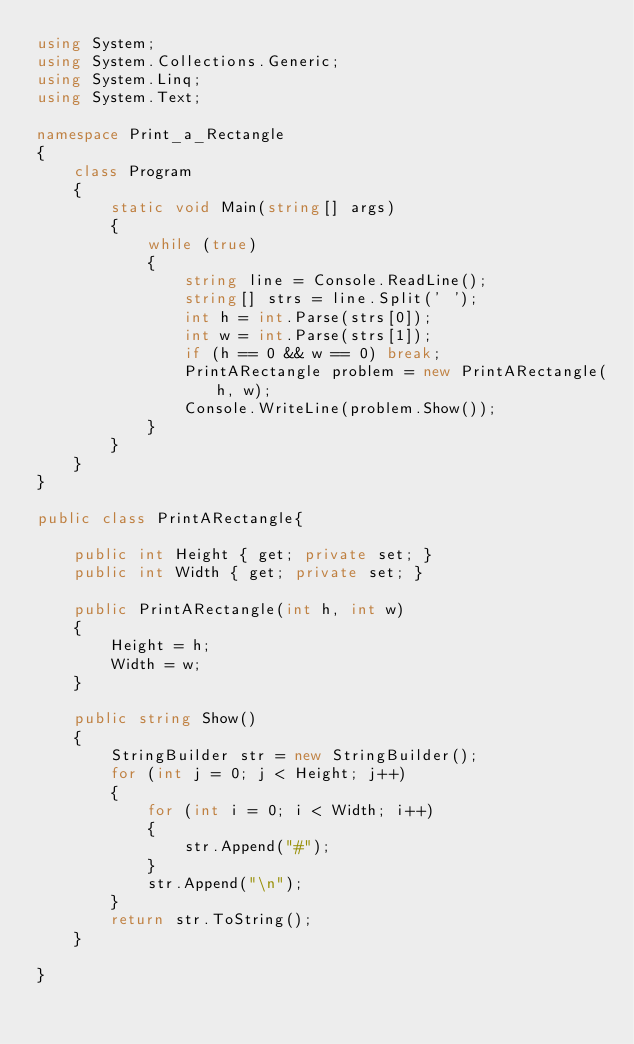Convert code to text. <code><loc_0><loc_0><loc_500><loc_500><_C#_>using System;
using System.Collections.Generic;
using System.Linq;
using System.Text;

namespace Print_a_Rectangle
{
    class Program
    {
        static void Main(string[] args)
        {
            while (true)
            {
                string line = Console.ReadLine();
                string[] strs = line.Split(' ');
                int h = int.Parse(strs[0]);
                int w = int.Parse(strs[1]);
                if (h == 0 && w == 0) break;
                PrintARectangle problem = new PrintARectangle(h, w);
                Console.WriteLine(problem.Show());
            }
        }
    }
}

public class PrintARectangle{

    public int Height { get; private set; }
    public int Width { get; private set; }

    public PrintARectangle(int h, int w)
    {
        Height = h;
        Width = w;
    }

    public string Show()
    {
        StringBuilder str = new StringBuilder();
        for (int j = 0; j < Height; j++)
        {
            for (int i = 0; i < Width; i++)
            {
                str.Append("#");
            }
            str.Append("\n");
        }
        return str.ToString();
    }

}</code> 